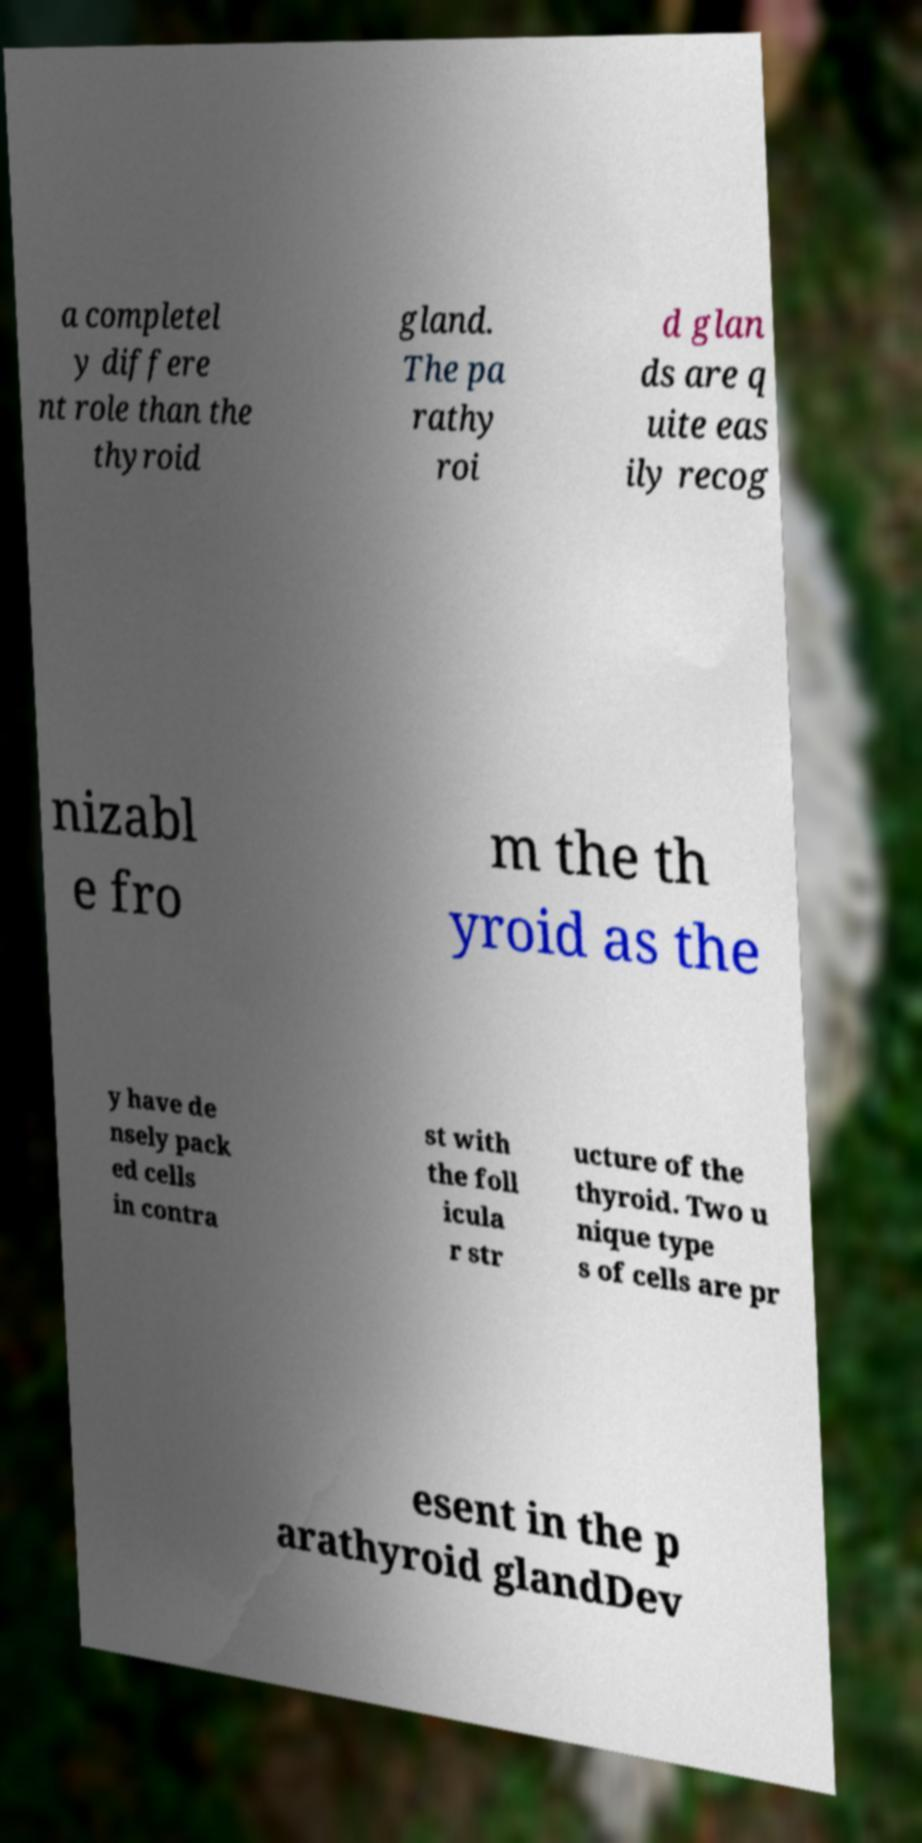For documentation purposes, I need the text within this image transcribed. Could you provide that? a completel y differe nt role than the thyroid gland. The pa rathy roi d glan ds are q uite eas ily recog nizabl e fro m the th yroid as the y have de nsely pack ed cells in contra st with the foll icula r str ucture of the thyroid. Two u nique type s of cells are pr esent in the p arathyroid glandDev 